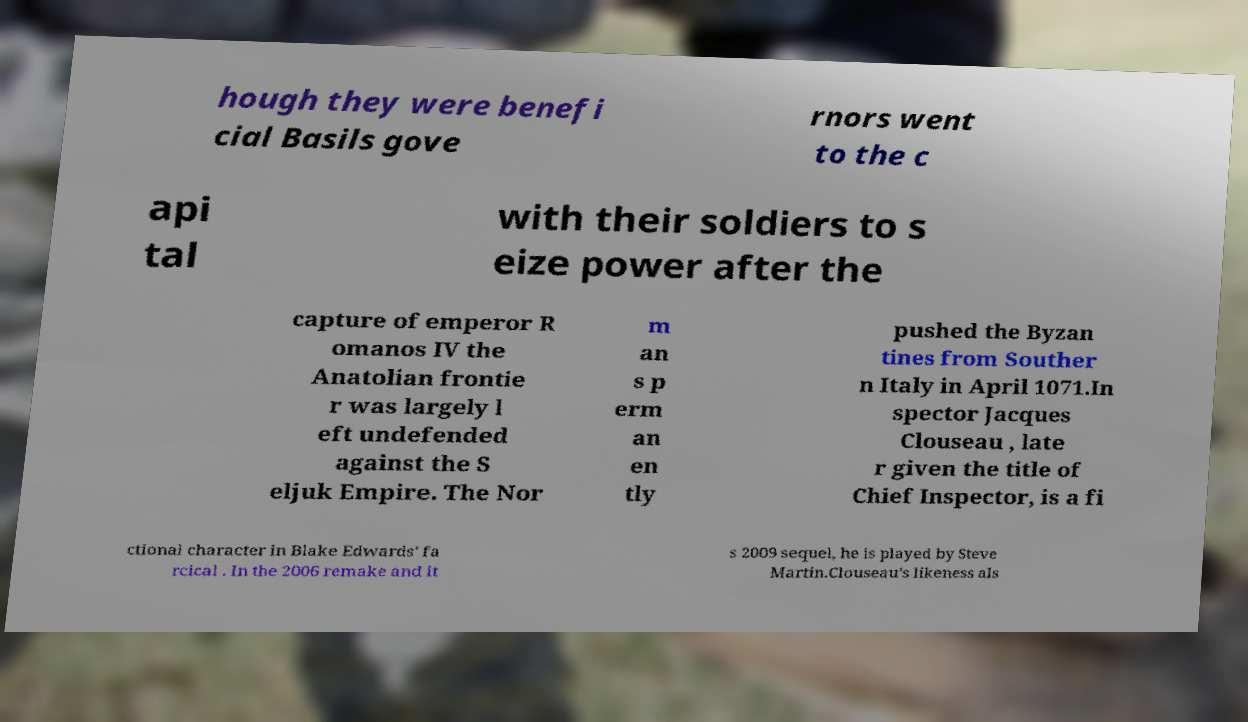What messages or text are displayed in this image? I need them in a readable, typed format. hough they were benefi cial Basils gove rnors went to the c api tal with their soldiers to s eize power after the capture of emperor R omanos IV the Anatolian frontie r was largely l eft undefended against the S eljuk Empire. The Nor m an s p erm an en tly pushed the Byzan tines from Souther n Italy in April 1071.In spector Jacques Clouseau , late r given the title of Chief Inspector, is a fi ctional character in Blake Edwards' fa rcical . In the 2006 remake and it s 2009 sequel, he is played by Steve Martin.Clouseau's likeness als 